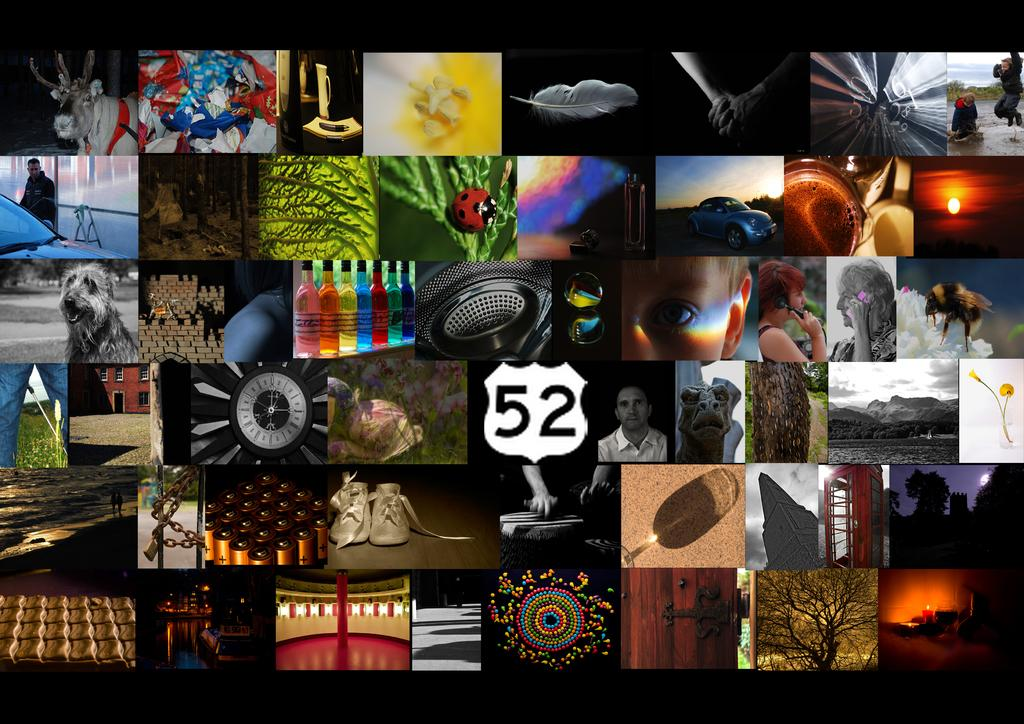<image>
Share a concise interpretation of the image provided. a collage of different photos with one that says '52' on it 